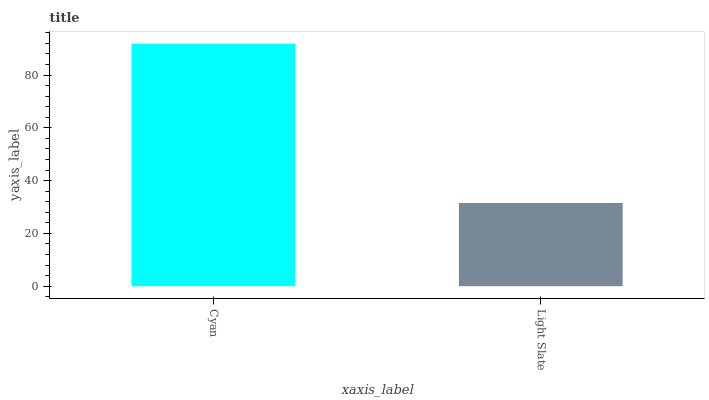Is Light Slate the maximum?
Answer yes or no. No. Is Cyan greater than Light Slate?
Answer yes or no. Yes. Is Light Slate less than Cyan?
Answer yes or no. Yes. Is Light Slate greater than Cyan?
Answer yes or no. No. Is Cyan less than Light Slate?
Answer yes or no. No. Is Cyan the high median?
Answer yes or no. Yes. Is Light Slate the low median?
Answer yes or no. Yes. Is Light Slate the high median?
Answer yes or no. No. Is Cyan the low median?
Answer yes or no. No. 